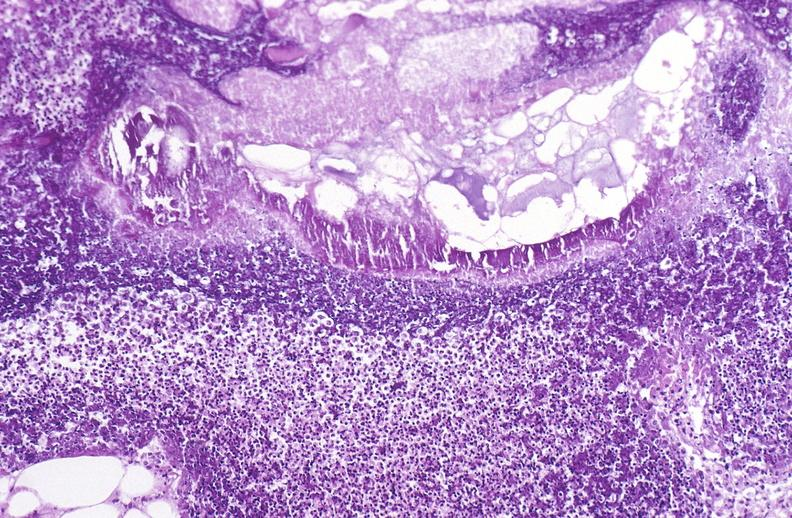what does this image show?
Answer the question using a single word or phrase. Pancreatic fat necrosis 